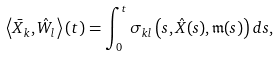Convert formula to latex. <formula><loc_0><loc_0><loc_500><loc_500>\left \langle \bar { X } _ { k } , \hat { W } _ { l } \right \rangle ( t ) = \int _ { 0 } ^ { t } \sigma _ { k l } \left ( s , \hat { X } ( s ) , \mathfrak { m } ( s ) \right ) d s ,</formula> 